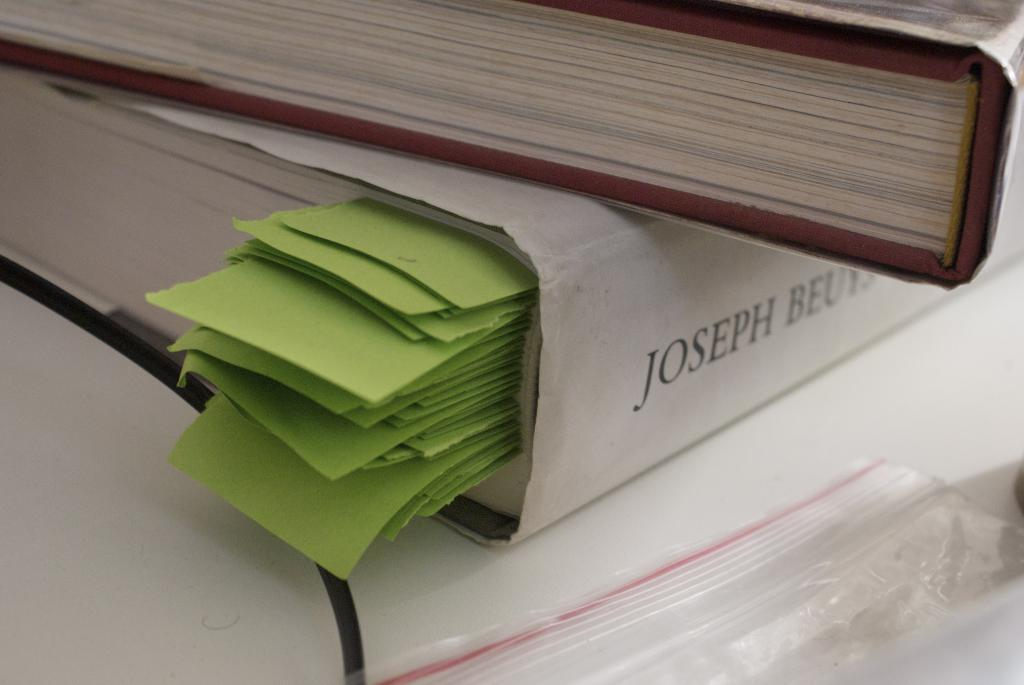<image>
Describe the image concisely. A picture of a thick book with green bookmarks that reads JOSEPH BEU. 